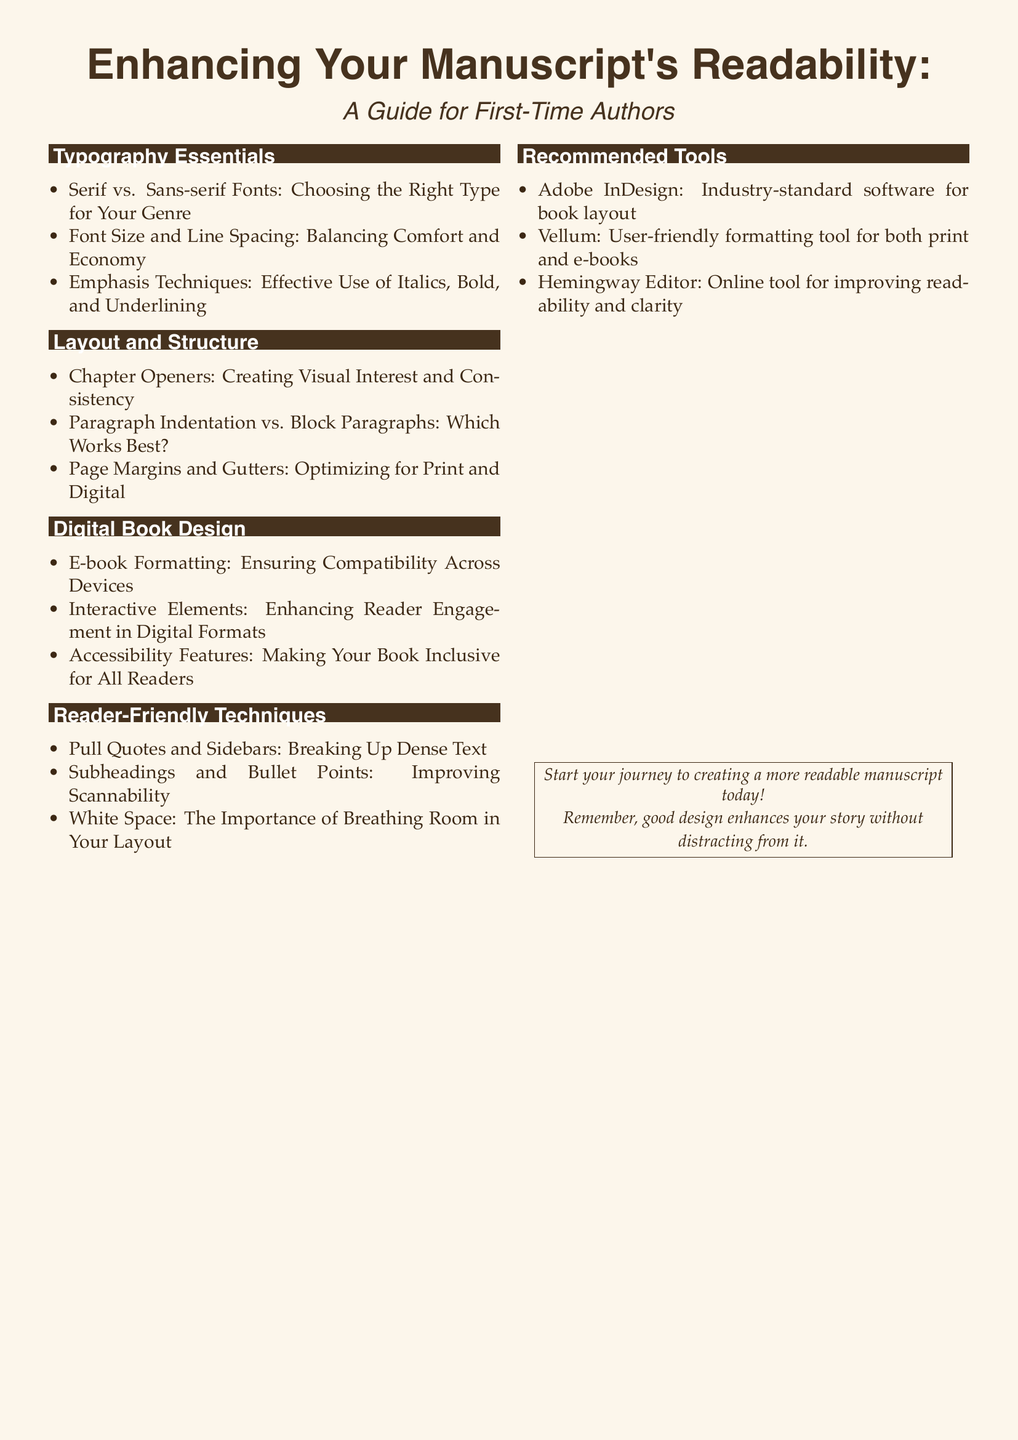What is the main font used in the document? The main font is specified using the '\setmainfont' command in the document, which states that Palatino is being used.
Answer: Palatino What section discusses typography? The section title "Typography Essentials" indicates that this part of the document covers typography-related topics.
Answer: Typography Essentials How many topics are listed under Digital Book Design? By counting the bullet points provided in the "Digital Book Design" section, we can determine the number of topics it covers.
Answer: Three Which tool is mentioned for improving readability and clarity? The document lists Hemingway Editor as a tool aimed at enhancing readability and clarity for manuscripts.
Answer: Hemingway Editor What color is used for the background of the document? The 'bgColor' defined in the code corresponds to an RGB value that indicates the background color, which is a light color.
Answer: Light pinkish What does the document suggest for breaking up dense text? The document specifically mentions "Pull Quotes and Sidebars" as a technique to break up dense text.
Answer: Pull Quotes and Sidebars How is reader engagement enhanced in digital formats according to the document? The document refers to "Interactive Elements" as methods for enhancing reader engagement in digital formats.
Answer: Interactive Elements What is the recommended software for book layout? The document suggests Adobe InDesign as the industry-standard software for book layout in the recommended tools section.
Answer: Adobe InDesign What importance does white space have according to the content? The document emphasizes that "White Space" provides necessary breathing room in the layout, which aids in readability.
Answer: Breathing room 